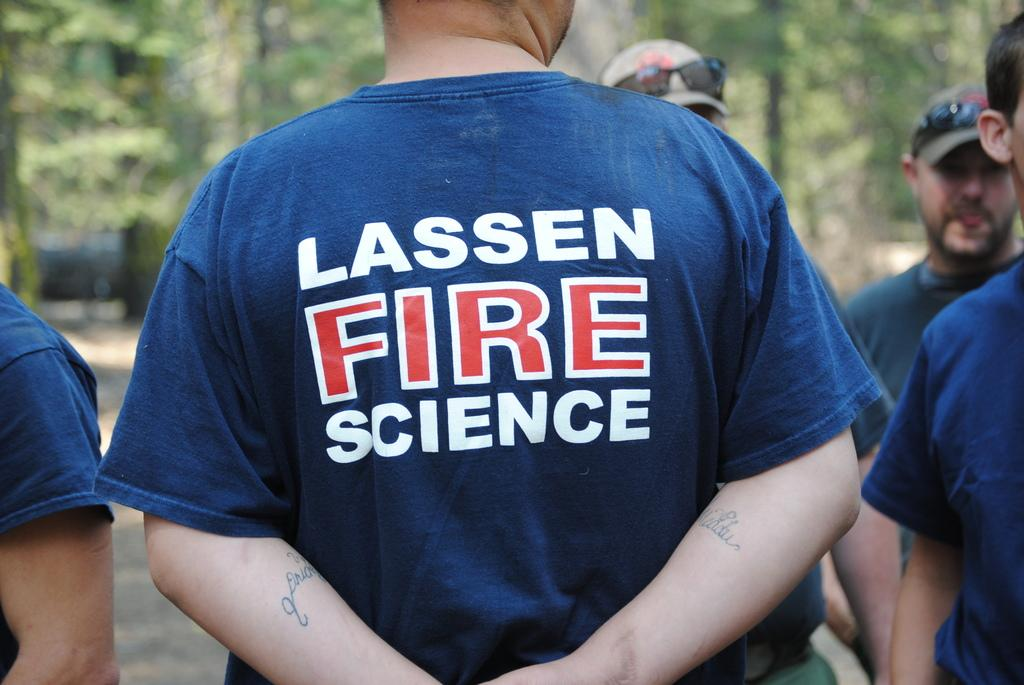<image>
Summarize the visual content of the image. A man stands with his back to the camera wearing a blue top with Lassen Fire Science written on it. 